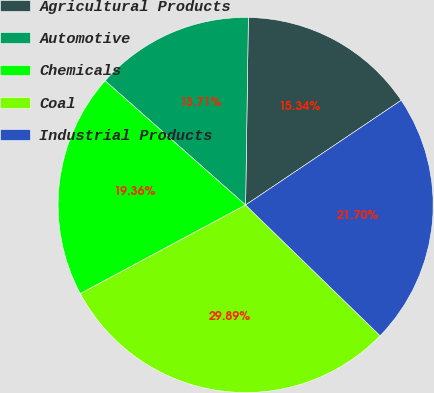Convert chart. <chart><loc_0><loc_0><loc_500><loc_500><pie_chart><fcel>Agricultural Products<fcel>Automotive<fcel>Chemicals<fcel>Coal<fcel>Industrial Products<nl><fcel>15.34%<fcel>13.71%<fcel>19.36%<fcel>29.89%<fcel>21.7%<nl></chart> 